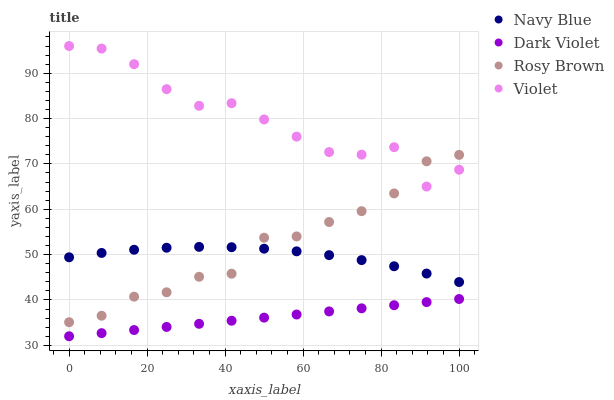Does Dark Violet have the minimum area under the curve?
Answer yes or no. Yes. Does Violet have the maximum area under the curve?
Answer yes or no. Yes. Does Rosy Brown have the minimum area under the curve?
Answer yes or no. No. Does Rosy Brown have the maximum area under the curve?
Answer yes or no. No. Is Dark Violet the smoothest?
Answer yes or no. Yes. Is Violet the roughest?
Answer yes or no. Yes. Is Rosy Brown the smoothest?
Answer yes or no. No. Is Rosy Brown the roughest?
Answer yes or no. No. Does Dark Violet have the lowest value?
Answer yes or no. Yes. Does Rosy Brown have the lowest value?
Answer yes or no. No. Does Violet have the highest value?
Answer yes or no. Yes. Does Rosy Brown have the highest value?
Answer yes or no. No. Is Navy Blue less than Violet?
Answer yes or no. Yes. Is Navy Blue greater than Dark Violet?
Answer yes or no. Yes. Does Navy Blue intersect Rosy Brown?
Answer yes or no. Yes. Is Navy Blue less than Rosy Brown?
Answer yes or no. No. Is Navy Blue greater than Rosy Brown?
Answer yes or no. No. Does Navy Blue intersect Violet?
Answer yes or no. No. 